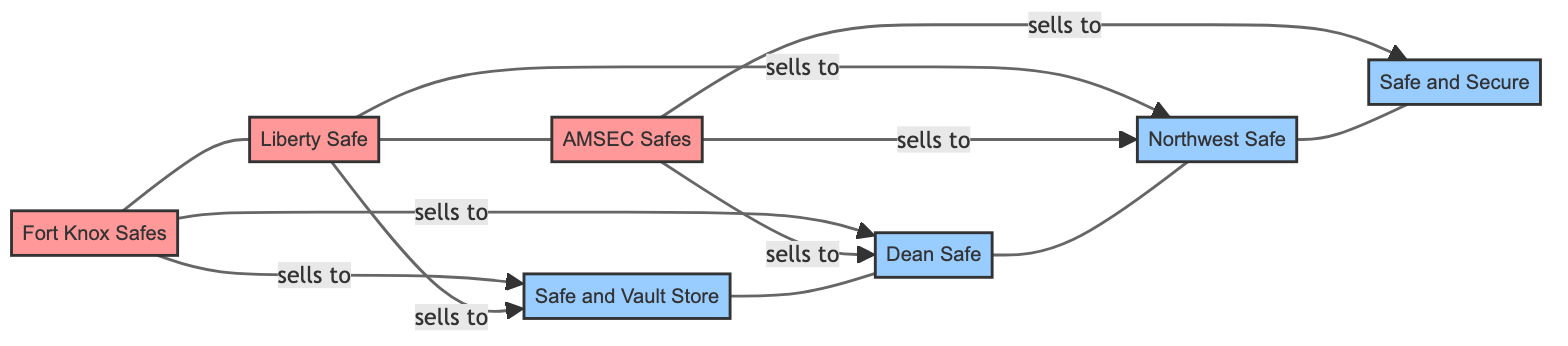What types of nodes are present in this diagram? The diagram has two types of nodes: Manufacturers and Dealers. By examining the node definitions, we can categorize them accordingly. Manufacturers are represented by Fort Knox Safes, Liberty Safe, and AMSEC Safes, while Dealers include Safe and Vault Store, Dean Safe, Northwest Safe, and Safe and Secure.
Answer: Manufacturers and Dealers How many nodes are in the diagram? The diagram contains a total of seven nodes. By counting each node entry in the data, we find three manufacturers and four dealers, resulting in a cumulative total of seven unique nodes.
Answer: Seven Which dealer sells products from AMSEC Safes? The dealers that sell AMSEC Safes products are Dean Safe and Safe and Secure. By tracing the links stemming from AMSEC Safes, we find two connections that indicate sales to these two dealers.
Answer: Dean Safe and Safe and Secure How many dealers does Fort Knox Safes sell to? Fort Knox Safes has links to two dealers: Safe and Vault Store and Dean Safe. By checking the connections in the diagram, we can see that there are exactly two sales relationships defined for Fort Knox Safes.
Answer: Two Which manufacturer sells to Northwest Safe? The manufacturer that sells to Northwest Safe is AMSEC Safes. By examining the connections in the diagram, there is a direct link from AMSEC Safes to Northwest Safe indicating that it is a seller for that dealer.
Answer: AMSEC Safes What is the total number of relationships in the diagram? The total number of relationships, denoted by the links between nodes, amounts to six. By reviewing the links section in the data, we see that there are six connections described, each representing a sales relationship between manufacturers and dealers.
Answer: Six Which two manufacturers share a dealer in common? Fort Knox Safes and Liberty Safe both share their dealer, Safe and Vault Store. By analyzing the diagram's relationships, we find that both manufacturers have a direct connection to the same dealer, indicating they both sell to Safe and Vault Store.
Answer: Fort Knox Safes and Liberty Safe Which dealer is the only one selling products from Liberty Safe? The dealer selling products exclusively from Liberty Safe is Northwest Safe. Upon checking the link for Liberty Safe, it points only to Northwest Safe, establishing it as the single dealer for that manufacturer.
Answer: Northwest Safe 